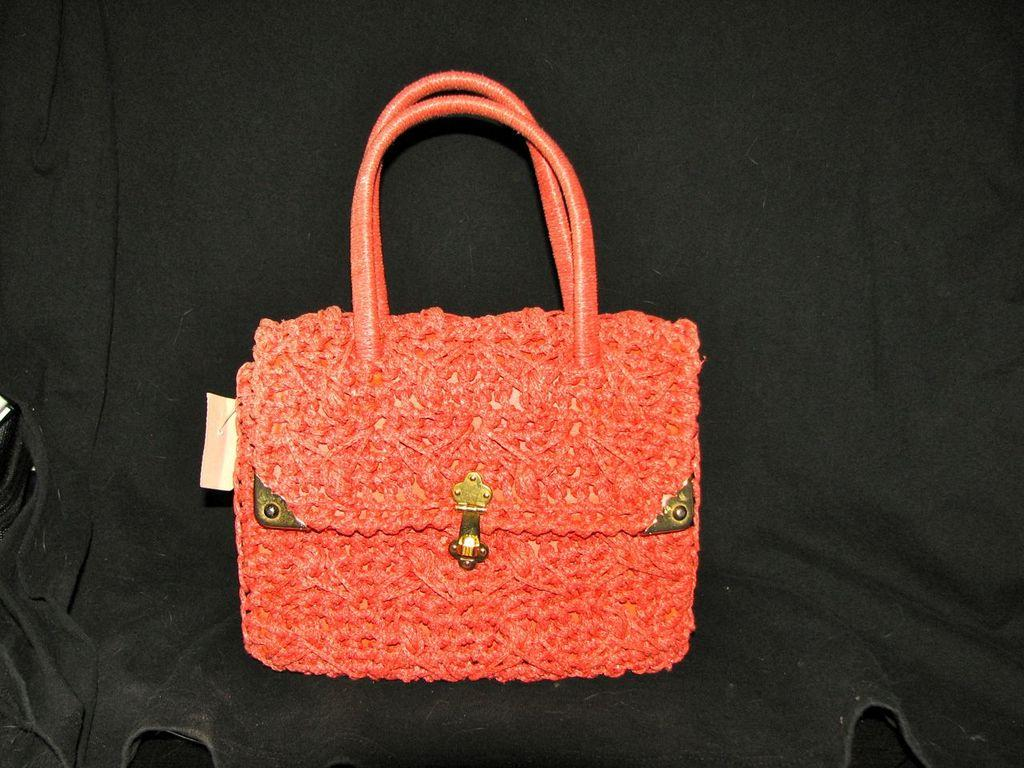What type of accessory is present in the image? There is a red color handbag in the image. Can you describe the color of the handbag? The handbag is red in color. How many geese are flying over the handbag in the image? There are no geese present in the image; it only features a red color handbag. 